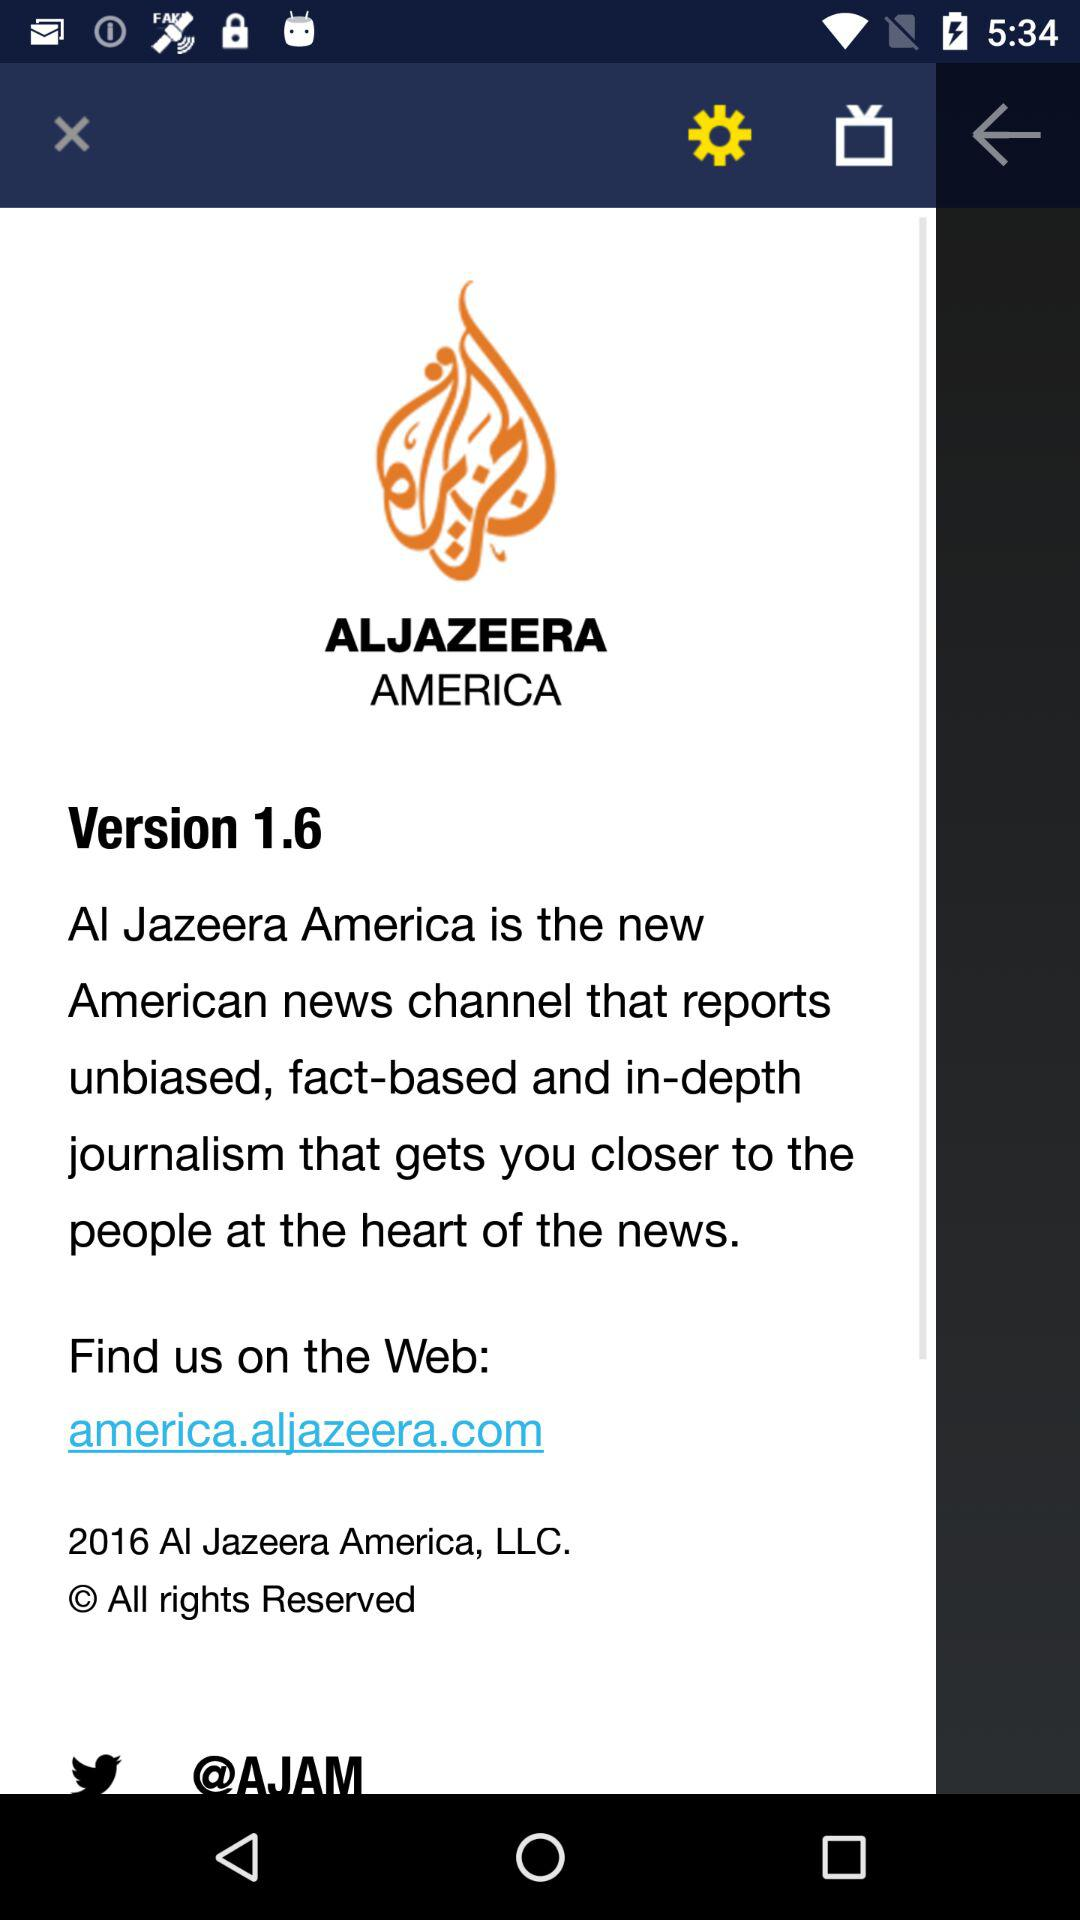What website can we visit for any help? For any help, you can visit america.aljazeera.com. 